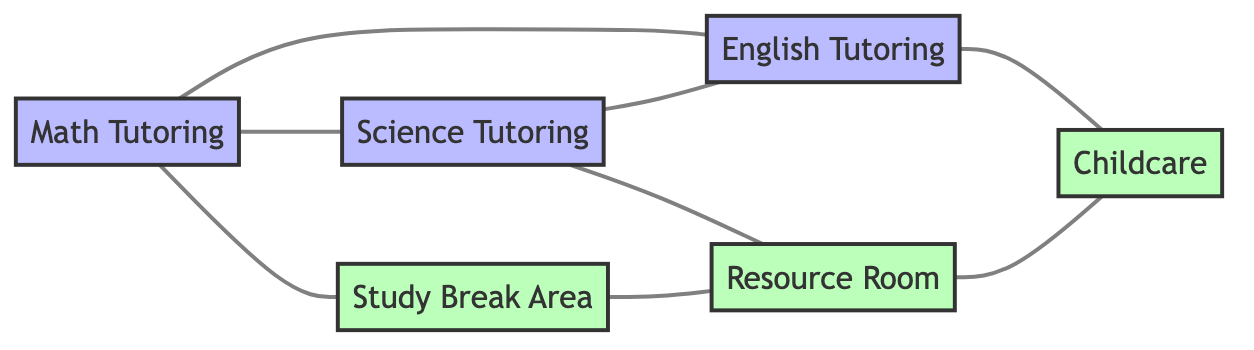What are the tutoring subjects offered? The diagram has three nodes related to tutoring: Math Tutoring, Science Tutoring, and English Tutoring.
Answer: Math Tutoring, Science Tutoring, English Tutoring How many nodes are there in total? Counting all the nodes in the diagram, we have 6 in total: 3 for tutoring sessions and 3 for facilities.
Answer: 6 What is the relationship between Math Tutoring and English Tutoring? The diagram shows that Math Tutoring and English Tutoring are adjacent, meaning they are directly connected by an edge.
Answer: adjacent Which facility is connected to the Resource Room? From the diagram, we see two facilities connected to the Resource Room: Science Tutoring and the Study Break Area.
Answer: Science Tutoring, Study Break Area How many edges are connected to Childcare? Looking at the diagram, Childcare is connected to English Tutoring and Resource Room, totaling 2 edges.
Answer: 2 Which tutoring session is connected to the Study Break Area? From the visual information, Math Tutoring is the session that connects directly to the Study Break Area.
Answer: Math Tutoring Is there a direct connection between the Science Tutoring and Math Tutoring? The diagram indicates that there is a direct connection (they are adjacent) between Science Tutoring and Math Tutoring.
Answer: yes Which nodes have a connected relationship? Analyzing the edges, the following pairs have a connected relationship: Math and Study Break Area, Science and Resource Room, and English and Childcare, along with others.
Answer: Math-Study Break Area, Science-Resource Room, English-Childcare, Study Break Area-Resource Room, Resource Room-Childcare How many tutoring sessions are adjacent to each other? In the diagram, all three tutoring sessions (Math Tutoring, Science Tutoring, and English Tutoring) are adjacent to at least one other tutoring session, totaling 3 adjacent pairs.
Answer: 3 